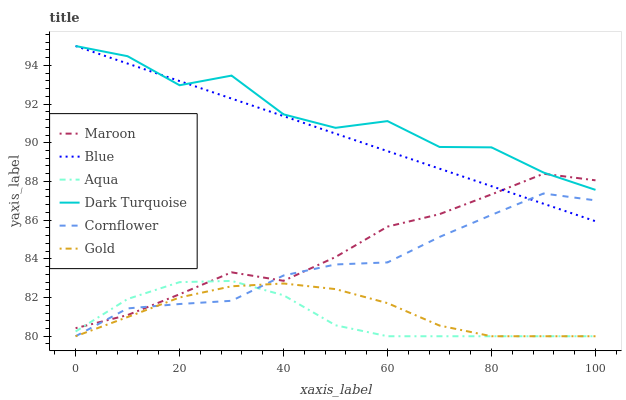Does Aqua have the minimum area under the curve?
Answer yes or no. Yes. Does Dark Turquoise have the maximum area under the curve?
Answer yes or no. Yes. Does Cornflower have the minimum area under the curve?
Answer yes or no. No. Does Cornflower have the maximum area under the curve?
Answer yes or no. No. Is Blue the smoothest?
Answer yes or no. Yes. Is Dark Turquoise the roughest?
Answer yes or no. Yes. Is Cornflower the smoothest?
Answer yes or no. No. Is Cornflower the roughest?
Answer yes or no. No. Does Cornflower have the lowest value?
Answer yes or no. Yes. Does Dark Turquoise have the lowest value?
Answer yes or no. No. Does Dark Turquoise have the highest value?
Answer yes or no. Yes. Does Cornflower have the highest value?
Answer yes or no. No. Is Aqua less than Blue?
Answer yes or no. Yes. Is Blue greater than Aqua?
Answer yes or no. Yes. Does Aqua intersect Cornflower?
Answer yes or no. Yes. Is Aqua less than Cornflower?
Answer yes or no. No. Is Aqua greater than Cornflower?
Answer yes or no. No. Does Aqua intersect Blue?
Answer yes or no. No. 